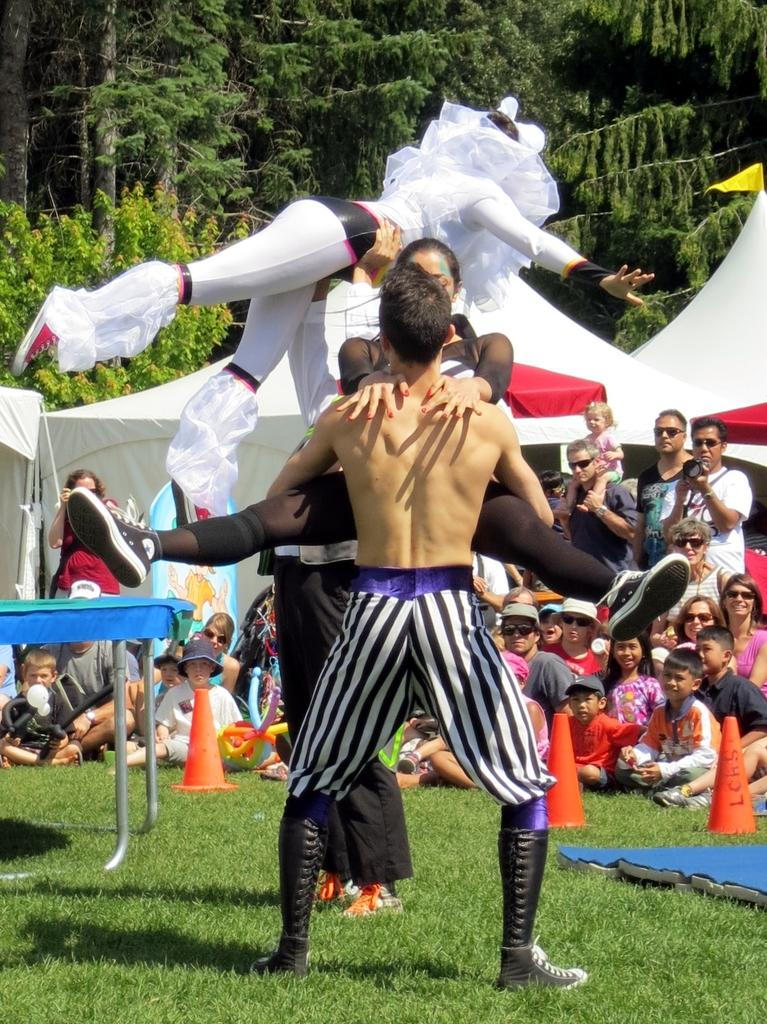How many people are in the image? There is a group of people in the image, but the exact number is not specified. What are the people in the image doing? Some people are seated on the grass, while others are standing. What can be seen in the background of the image? There are tents, trees, road divider cones, and a table in the background of the image. What type of furniture is being used by the sister in the image? There is no mention of a sister or furniture in the image. What color is the crayon being used by the person in the image? There is no crayon present in the image. 